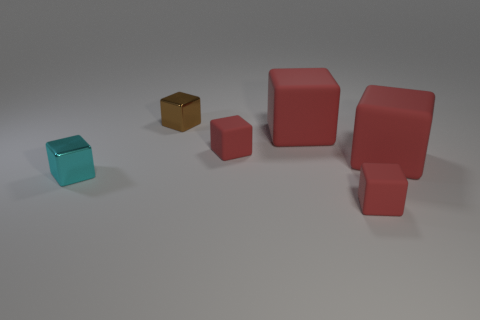There is a red cube that is in front of the tiny cyan shiny block; what is it made of?
Keep it short and to the point. Rubber. How many things are metallic objects in front of the tiny brown thing or small rubber cubes?
Your response must be concise. 3. Are there the same number of red objects that are behind the small cyan block and shiny objects?
Offer a very short reply. No. Do the cyan shiny object and the brown thing have the same size?
Give a very brief answer. Yes. What is the color of the other metallic block that is the same size as the brown metallic cube?
Offer a very short reply. Cyan. Is the size of the brown thing the same as the red block that is in front of the small cyan block?
Keep it short and to the point. Yes. What number of things are either tiny shiny blocks or small rubber objects that are behind the cyan thing?
Offer a very short reply. 3. Is there a cyan block made of the same material as the brown object?
Provide a succinct answer. Yes. There is a cyan metal object; what shape is it?
Your response must be concise. Cube. What is the shape of the object that is on the left side of the small shiny cube that is behind the cyan block?
Give a very brief answer. Cube. 